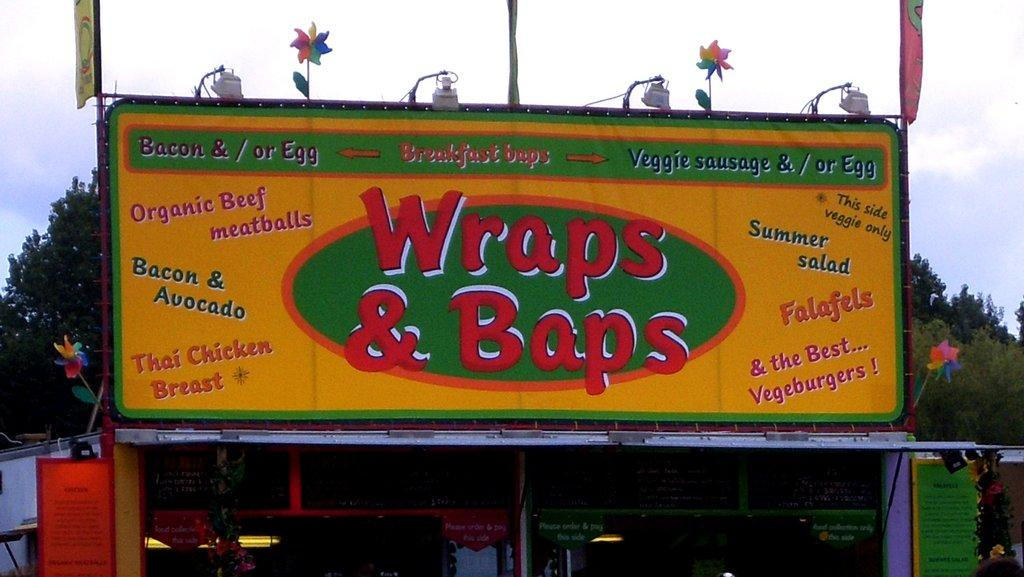Provide a one-sentence caption for the provided image. A small structure has a sign for Wraps and Baps above it, including various dishes that they serve on it. 